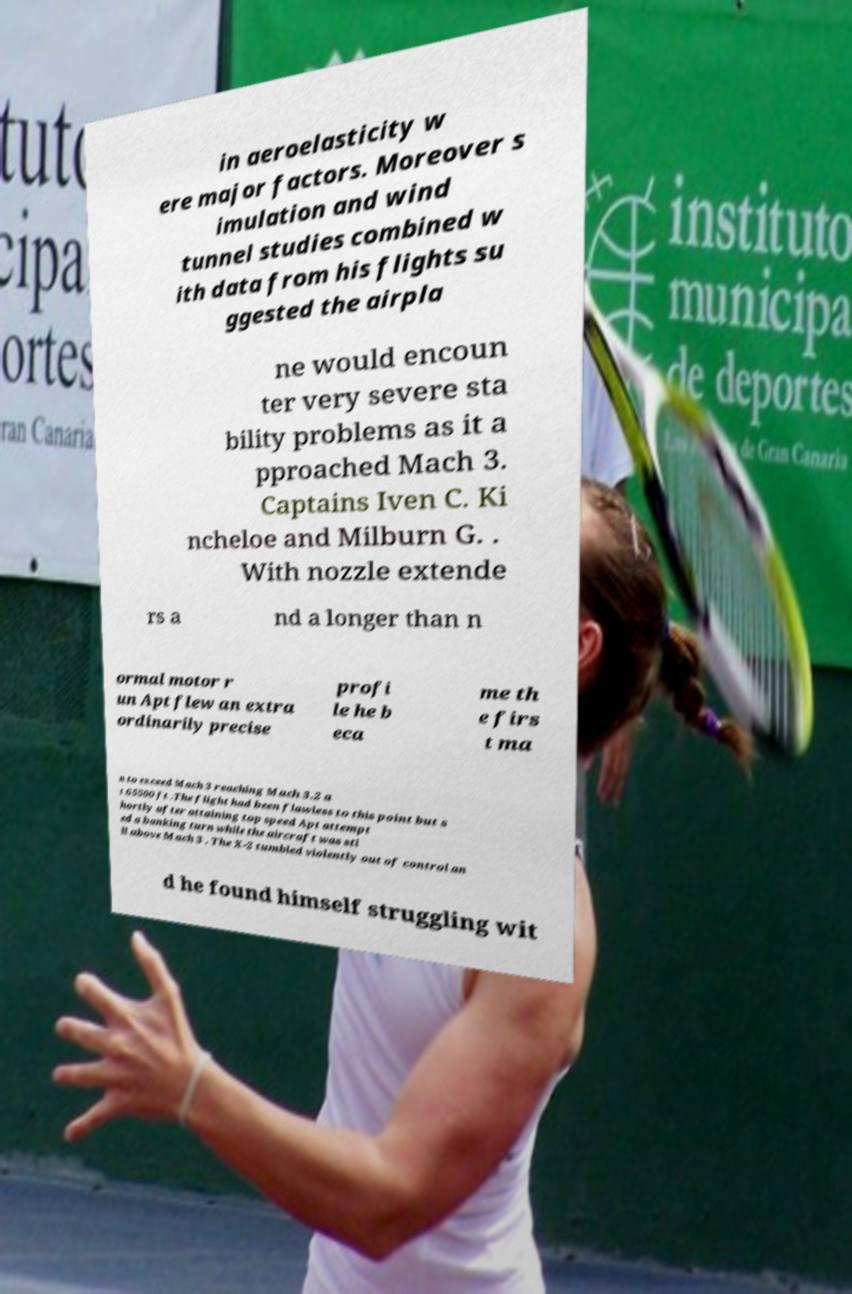Could you assist in decoding the text presented in this image and type it out clearly? in aeroelasticity w ere major factors. Moreover s imulation and wind tunnel studies combined w ith data from his flights su ggested the airpla ne would encoun ter very severe sta bility problems as it a pproached Mach 3. Captains Iven C. Ki ncheloe and Milburn G. . With nozzle extende rs a nd a longer than n ormal motor r un Apt flew an extra ordinarily precise profi le he b eca me th e firs t ma n to exceed Mach 3 reaching Mach 3.2 a t 65500 ft .The flight had been flawless to this point but s hortly after attaining top speed Apt attempt ed a banking turn while the aircraft was sti ll above Mach 3 . The X-2 tumbled violently out of control an d he found himself struggling wit 